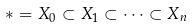Convert formula to latex. <formula><loc_0><loc_0><loc_500><loc_500>* = X _ { 0 } \subset X _ { 1 } \subset \dots \subset X _ { n }</formula> 